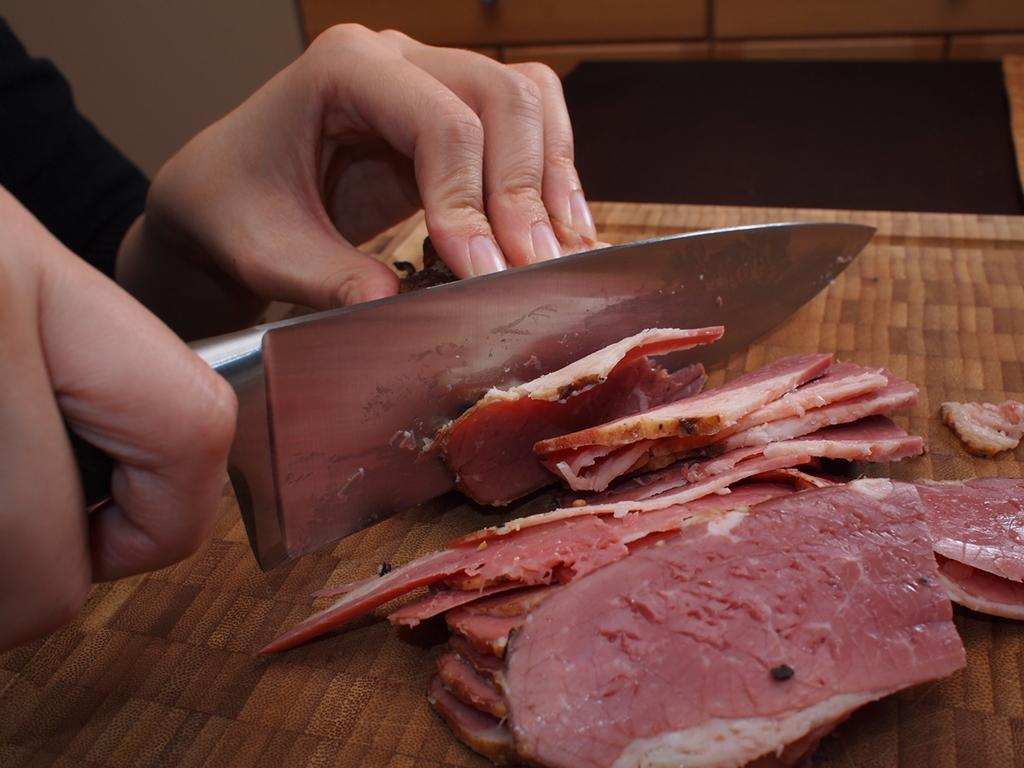What is the person holding in the image? The person is holding a stainless steel knife in the image. What type of food can be seen on the table in the image? Red meat pieces are visible on a table in the image. What color is the chalk on the floor in the image? There is no chalk or floor present in the image. What is the purpose of the person holding the knife in the image? The purpose of the person holding the knife cannot be determined from the image alone, as it could be for various reasons such as cooking, cutting, or even as a prop for a photo. 